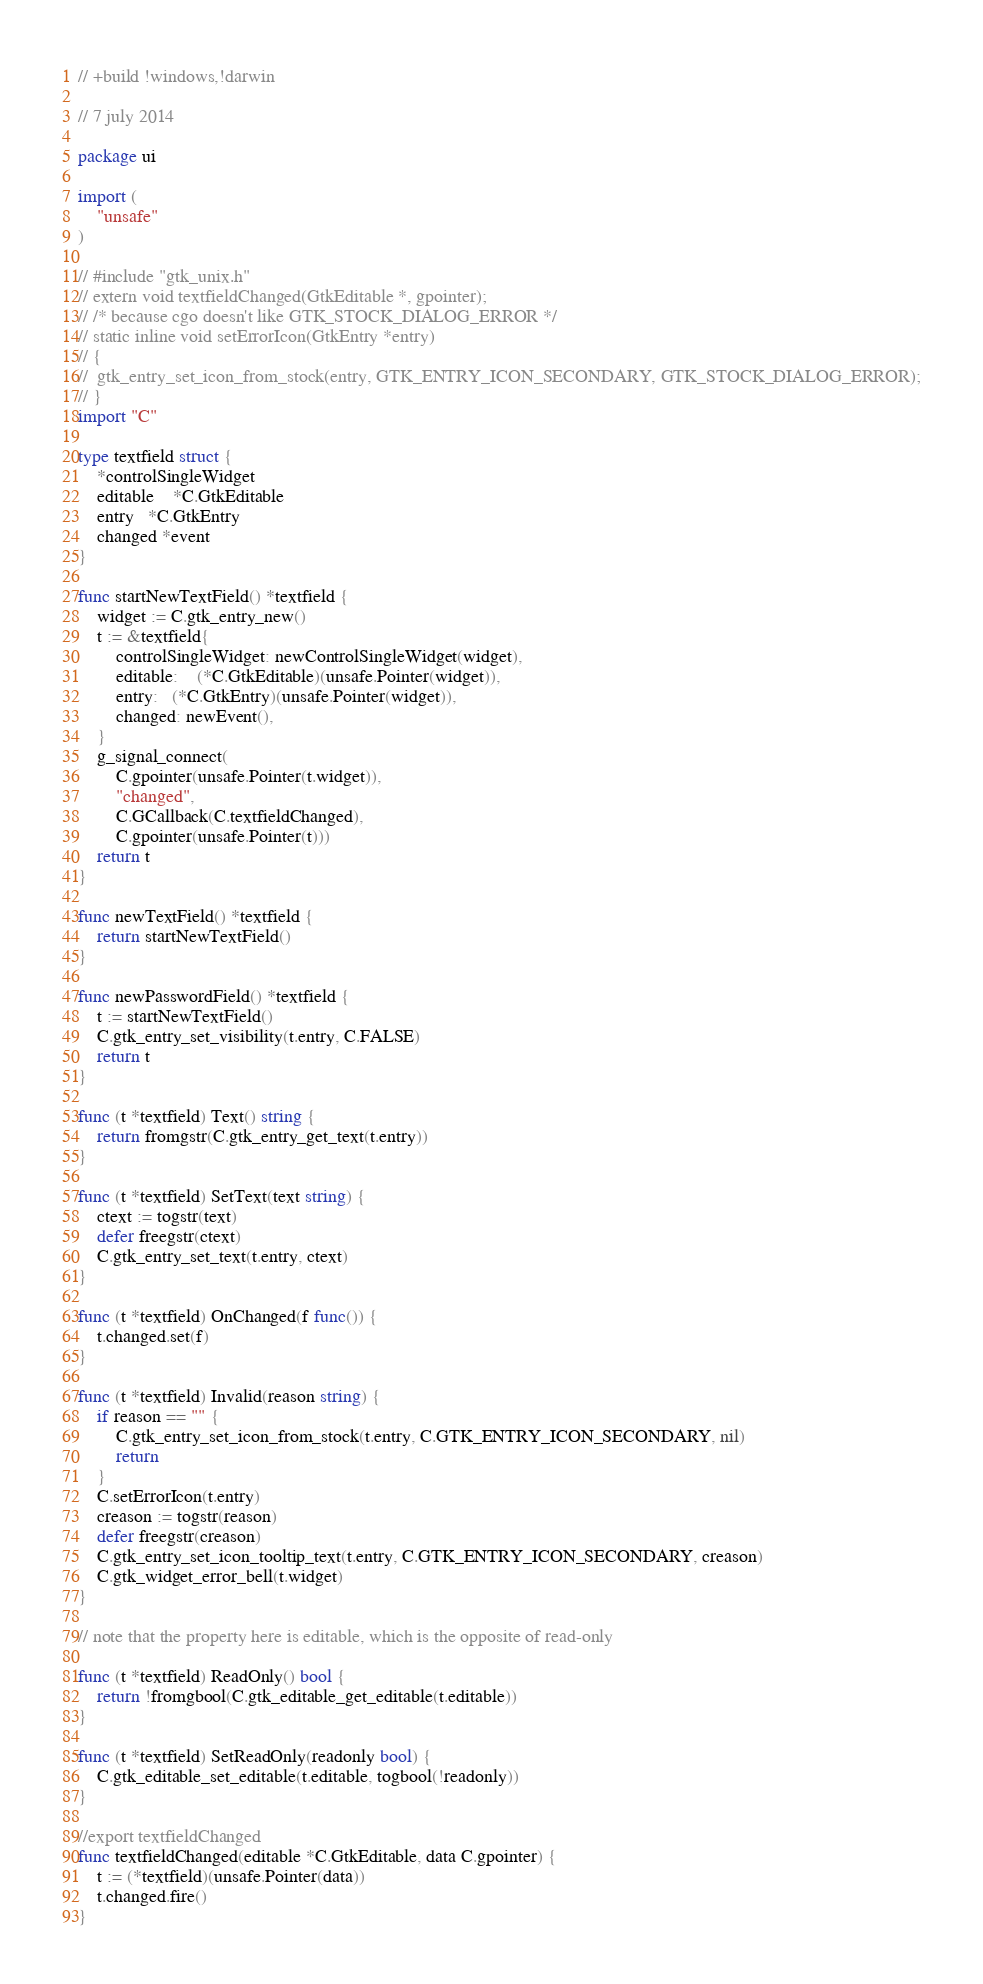<code> <loc_0><loc_0><loc_500><loc_500><_Go_>// +build !windows,!darwin

// 7 july 2014

package ui

import (
	"unsafe"
)

// #include "gtk_unix.h"
// extern void textfieldChanged(GtkEditable *, gpointer);
// /* because cgo doesn't like GTK_STOCK_DIALOG_ERROR */
// static inline void setErrorIcon(GtkEntry *entry)
// {
// 	gtk_entry_set_icon_from_stock(entry, GTK_ENTRY_ICON_SECONDARY, GTK_STOCK_DIALOG_ERROR);
// }
import "C"

type textfield struct {
	*controlSingleWidget
	editable	*C.GtkEditable
	entry   *C.GtkEntry
	changed *event
}

func startNewTextField() *textfield {
	widget := C.gtk_entry_new()
	t := &textfield{
		controlSingleWidget: newControlSingleWidget(widget),
		editable:	(*C.GtkEditable)(unsafe.Pointer(widget)),
		entry:   (*C.GtkEntry)(unsafe.Pointer(widget)),
		changed: newEvent(),
	}
	g_signal_connect(
		C.gpointer(unsafe.Pointer(t.widget)),
		"changed",
		C.GCallback(C.textfieldChanged),
		C.gpointer(unsafe.Pointer(t)))
	return t
}

func newTextField() *textfield {
	return startNewTextField()
}

func newPasswordField() *textfield {
	t := startNewTextField()
	C.gtk_entry_set_visibility(t.entry, C.FALSE)
	return t
}

func (t *textfield) Text() string {
	return fromgstr(C.gtk_entry_get_text(t.entry))
}

func (t *textfield) SetText(text string) {
	ctext := togstr(text)
	defer freegstr(ctext)
	C.gtk_entry_set_text(t.entry, ctext)
}

func (t *textfield) OnChanged(f func()) {
	t.changed.set(f)
}

func (t *textfield) Invalid(reason string) {
	if reason == "" {
		C.gtk_entry_set_icon_from_stock(t.entry, C.GTK_ENTRY_ICON_SECONDARY, nil)
		return
	}
	C.setErrorIcon(t.entry)
	creason := togstr(reason)
	defer freegstr(creason)
	C.gtk_entry_set_icon_tooltip_text(t.entry, C.GTK_ENTRY_ICON_SECONDARY, creason)
	C.gtk_widget_error_bell(t.widget)
}

// note that the property here is editable, which is the opposite of read-only

func (t *textfield) ReadOnly() bool {
	return !fromgbool(C.gtk_editable_get_editable(t.editable))
}

func (t *textfield) SetReadOnly(readonly bool) {
	C.gtk_editable_set_editable(t.editable, togbool(!readonly))
}

//export textfieldChanged
func textfieldChanged(editable *C.GtkEditable, data C.gpointer) {
	t := (*textfield)(unsafe.Pointer(data))
	t.changed.fire()
}
</code> 